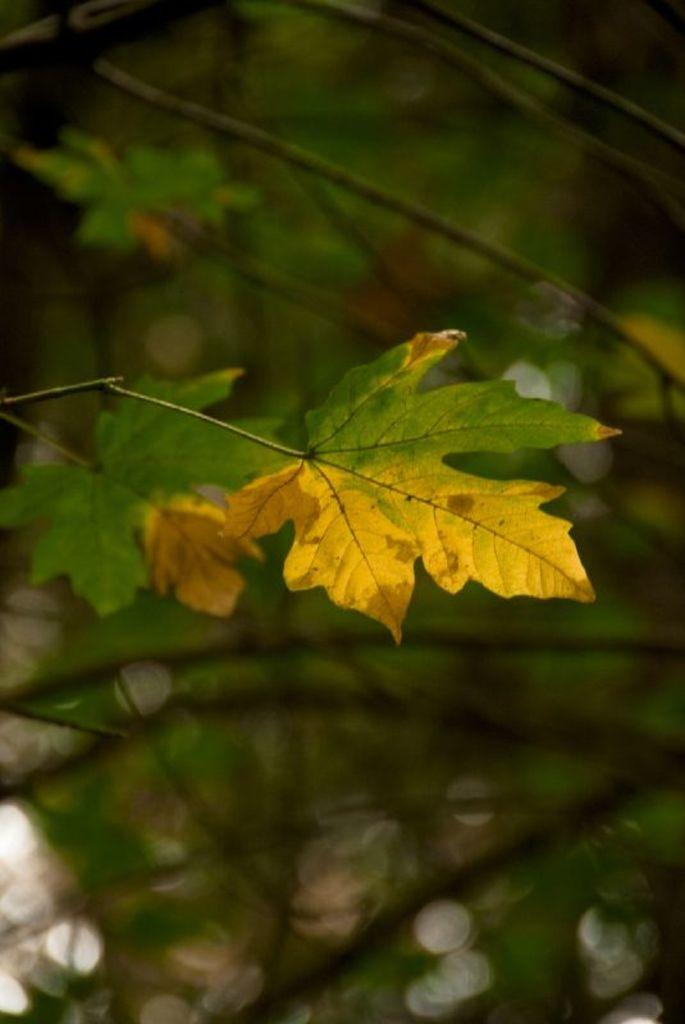What is the main object in the image? There is a leaf in the image. What type of natural environment is depicted in the image? There are trees in the image, suggesting a forest or wooded area. Can you describe any specific features of the image? There is a blurry area in the image, which may indicate movement or a lack of focus. What type of vacation is the manager planning in the image? There is no mention of a vacation or a manager in the image; it features a leaf and trees. 